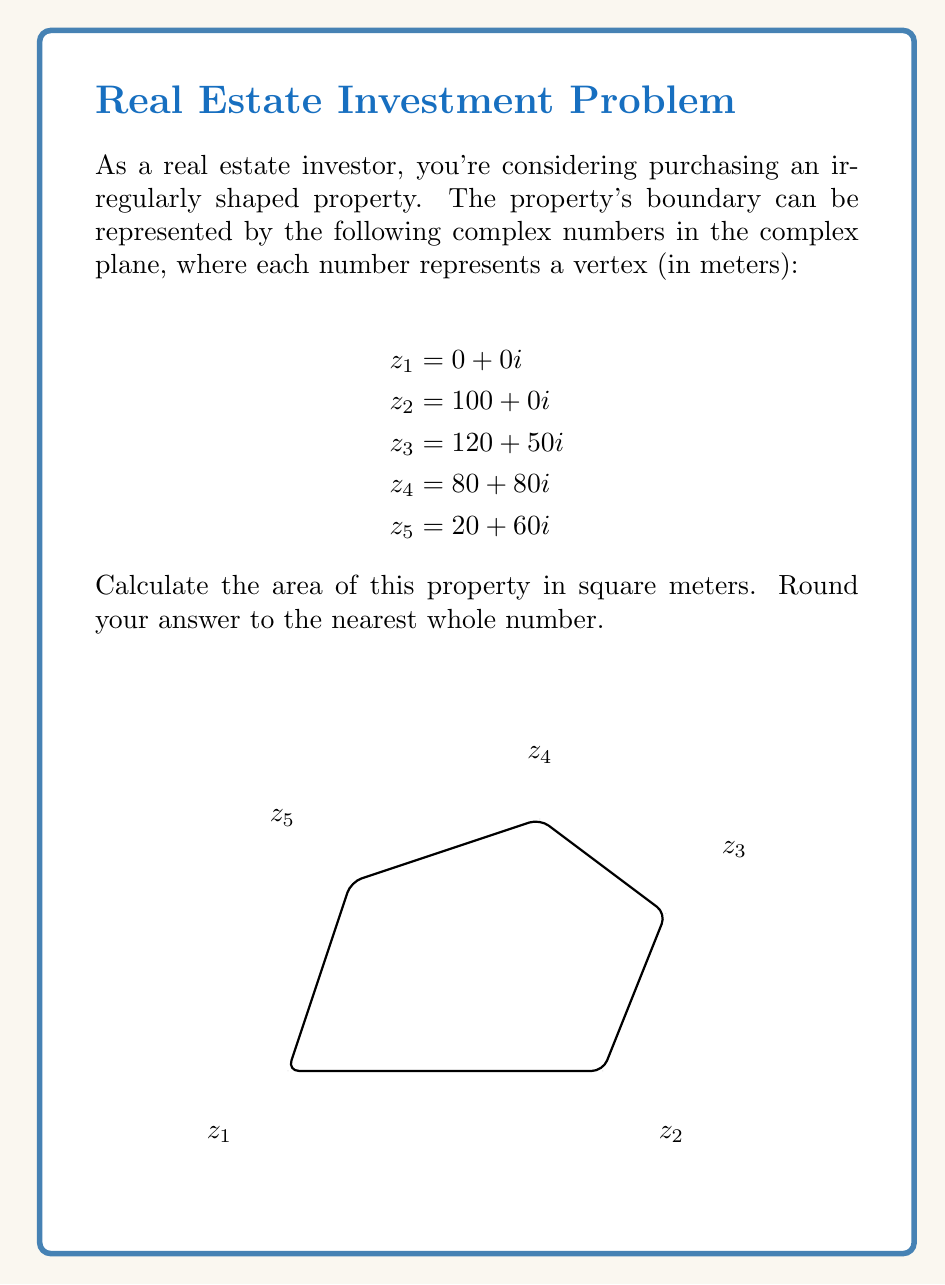Show me your answer to this math problem. To calculate the area of an irregularly shaped property using complex number representation, we can use the following formula:

$$A = \frac{1}{2}\left|\sum_{k=1}^{n} \text{Im}(z_k \overline{z_{k+1}})\right|$$

Where:
- $A$ is the area
- $z_k$ are the complex numbers representing the vertices
- $\overline{z_{k+1}}$ is the complex conjugate of the next vertex
- $\text{Im}()$ denotes the imaginary part of a complex number
- $n$ is the number of vertices (in this case, 5)
- $z_{n+1} = z_1$ (the property boundary is closed)

Let's calculate step by step:

1) First, we need to calculate $z_k \overline{z_{k+1}}$ for each pair of adjacent vertices:

   $z_1 \overline{z_2} = (0+0i)(100-0i) = 0$
   $z_2 \overline{z_3} = (100+0i)(120-50i) = 12000 - 5000i$
   $z_3 \overline{z_4} = (120+50i)(80-80i) = 13600 - 4000i$
   $z_4 \overline{z_5} = (80+80i)(20-60i) = 6400 - 3200i$
   $z_5 \overline{z_1} = (20+60i)(0-0i) = 0$

2) Now, we take the imaginary part of each result:

   $\text{Im}(0) = 0$
   $\text{Im}(12000 - 5000i) = -5000$
   $\text{Im}(13600 - 4000i) = -4000$
   $\text{Im}(6400 - 3200i) = -3200$
   $\text{Im}(0) = 0$

3) Sum these values:

   $0 + (-5000) + (-4000) + (-3200) + 0 = -12200$

4) Take the absolute value and divide by 2:

   $A = \frac{1}{2}|-12200| = 6100$

Therefore, the area of the property is 6100 square meters.
Answer: 6100 square meters 